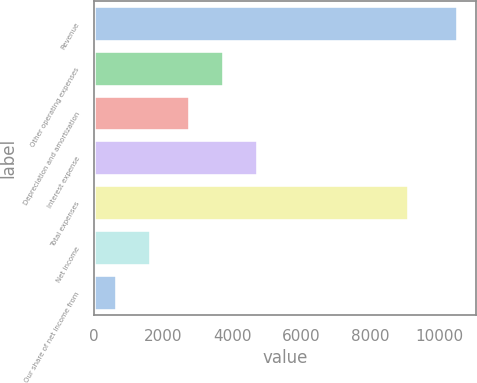Convert chart to OTSL. <chart><loc_0><loc_0><loc_500><loc_500><bar_chart><fcel>Revenue<fcel>Other operating expenses<fcel>Depreciation and amortization<fcel>Interest expense<fcel>Total expenses<fcel>Net income<fcel>Our share of net income from<nl><fcel>10523<fcel>3753.7<fcel>2767<fcel>4740.4<fcel>9101<fcel>1642.7<fcel>656<nl></chart> 